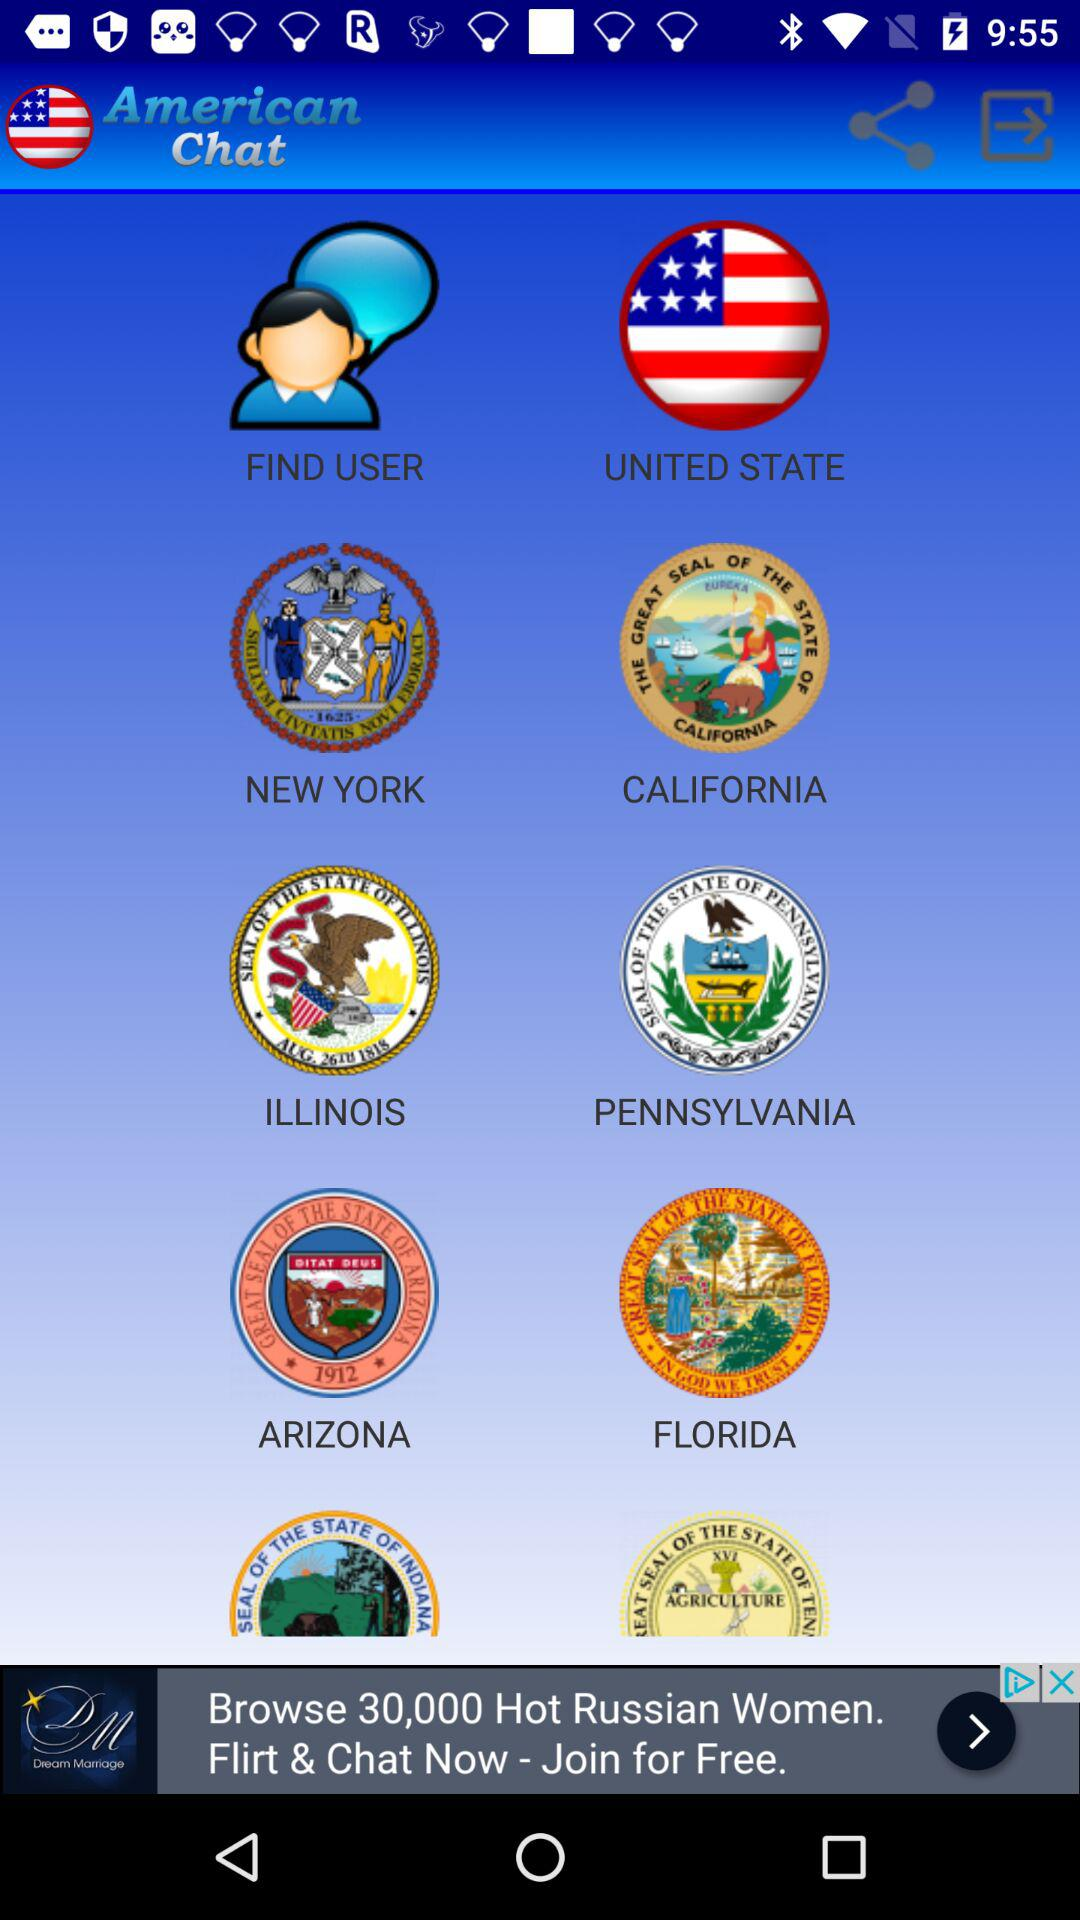Which state is the user from?
When the provided information is insufficient, respond with <no answer>. <no answer> 